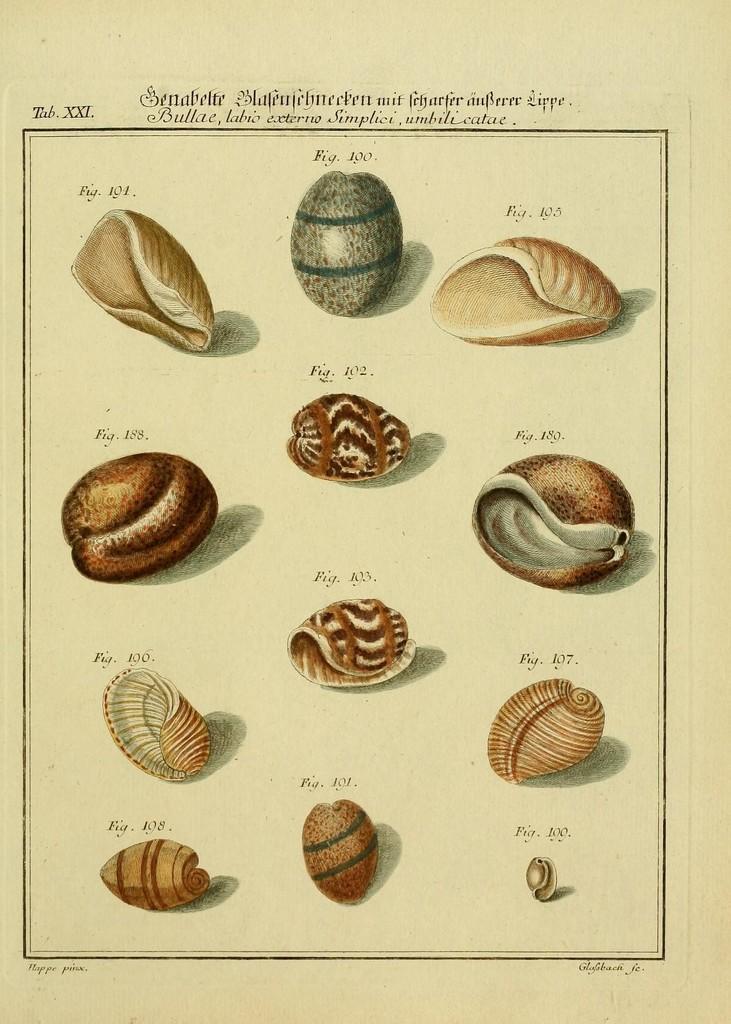Can you describe this image briefly? Here I can see the images of different types of shells on a white paper. At the top there is some text. 